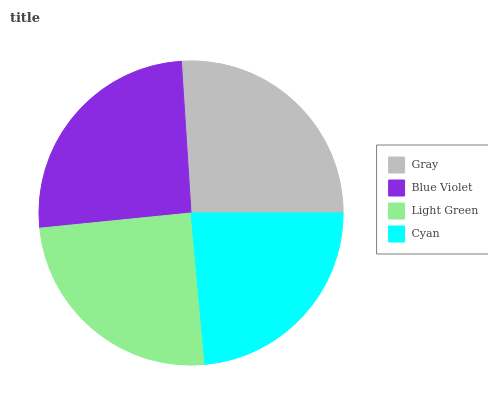Is Cyan the minimum?
Answer yes or no. Yes. Is Gray the maximum?
Answer yes or no. Yes. Is Blue Violet the minimum?
Answer yes or no. No. Is Blue Violet the maximum?
Answer yes or no. No. Is Gray greater than Blue Violet?
Answer yes or no. Yes. Is Blue Violet less than Gray?
Answer yes or no. Yes. Is Blue Violet greater than Gray?
Answer yes or no. No. Is Gray less than Blue Violet?
Answer yes or no. No. Is Blue Violet the high median?
Answer yes or no. Yes. Is Light Green the low median?
Answer yes or no. Yes. Is Cyan the high median?
Answer yes or no. No. Is Blue Violet the low median?
Answer yes or no. No. 